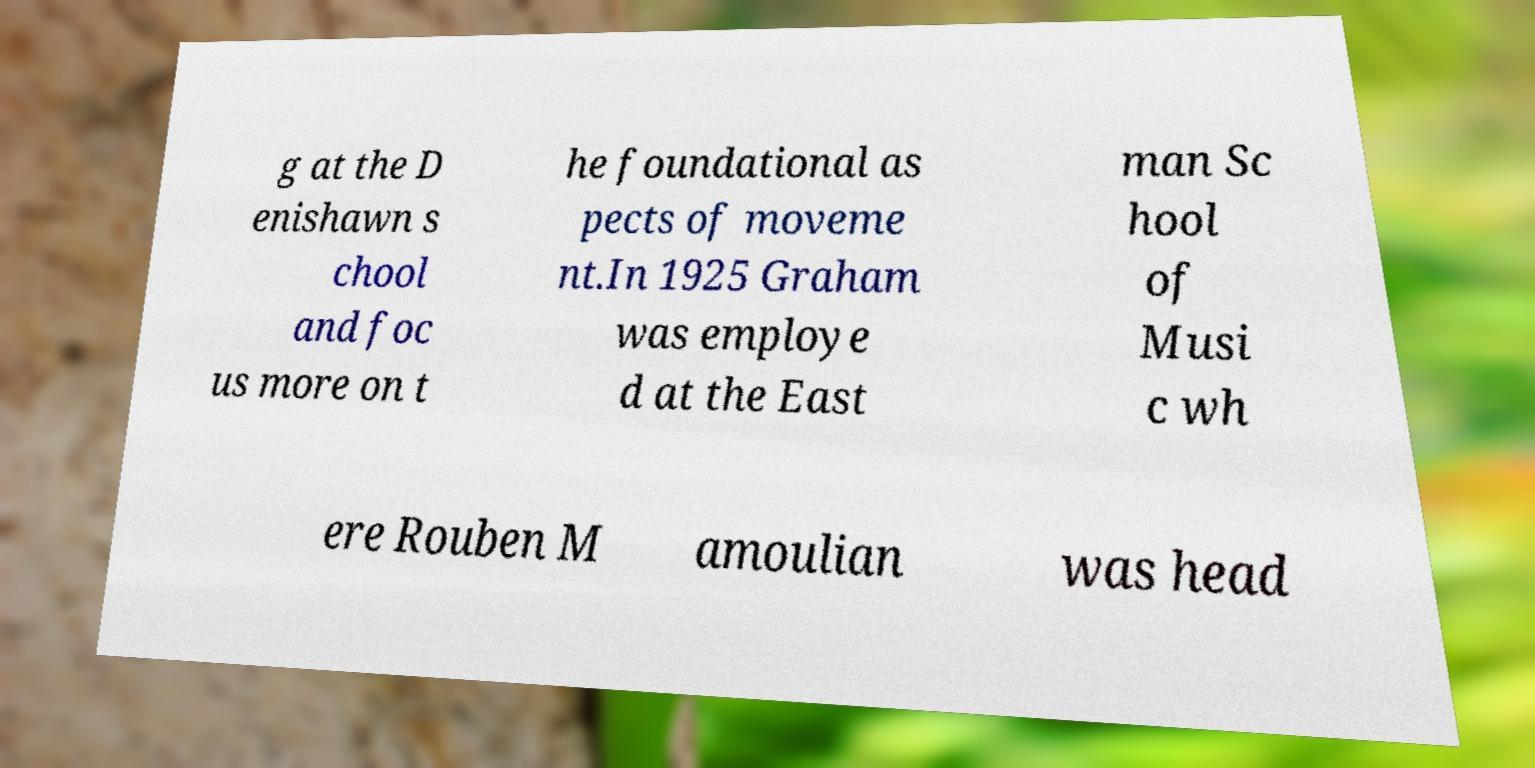There's text embedded in this image that I need extracted. Can you transcribe it verbatim? g at the D enishawn s chool and foc us more on t he foundational as pects of moveme nt.In 1925 Graham was employe d at the East man Sc hool of Musi c wh ere Rouben M amoulian was head 